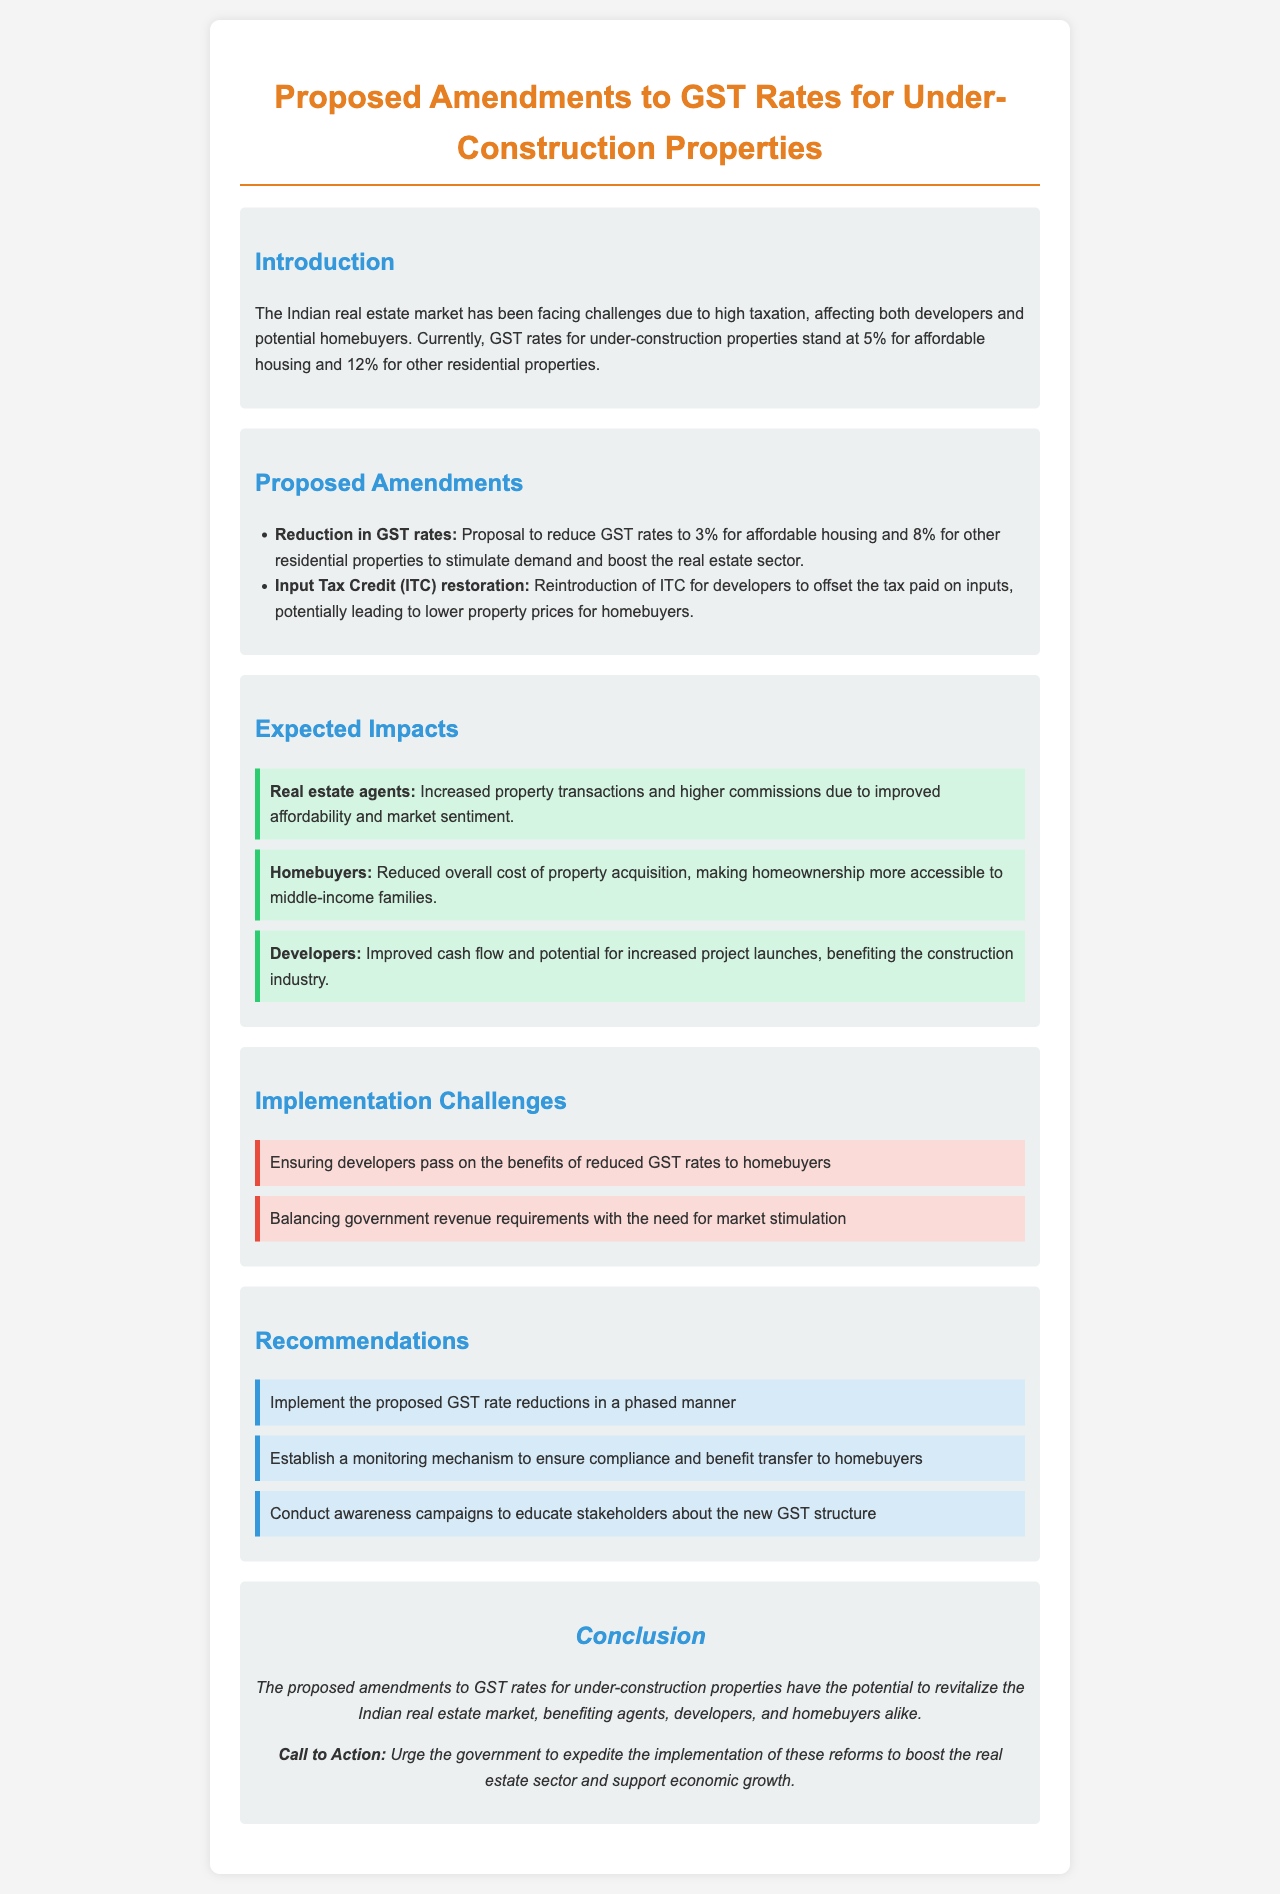What is the current GST rate for affordable housing? The current GST rate for affordable housing is mentioned in the introduction.
Answer: 5% What is the proposed GST rate for other residential properties? The proposed GST rate for other residential properties is listed under proposed amendments.
Answer: 8% What benefit is expected for homebuyers according to the expected impacts? The expected impacts section provides benefits to homebuyers, specifically affordability.
Answer: Reduced overall cost What is one challenge mentioned regarding the implementation of the proposed changes? The implementation challenges section highlights problems ensuring benefits reach homebuyers.
Answer: Ensuring benefits transfer What is one recommendation regarding the implementation of the GST rate reductions? The recommendations section suggests actions to ensure successful implementation of the proposed changes.
Answer: Implement in a phased manner What potential benefit is highlighted for real estate agents in the expected impacts? The expected impacts section outlines benefits to real estate agents due to market changes.
Answer: Increased property transactions What is the purpose of the proposed amendments to GST rates? The introduction explains the goals of the proposed amendments within the real estate market.
Answer: Stimulate demand What is the call to action mentioned in the conclusion? The conclusion provides a direct appeal related to the amendments, urging a specific response from the government.
Answer: Expedite the implementation 